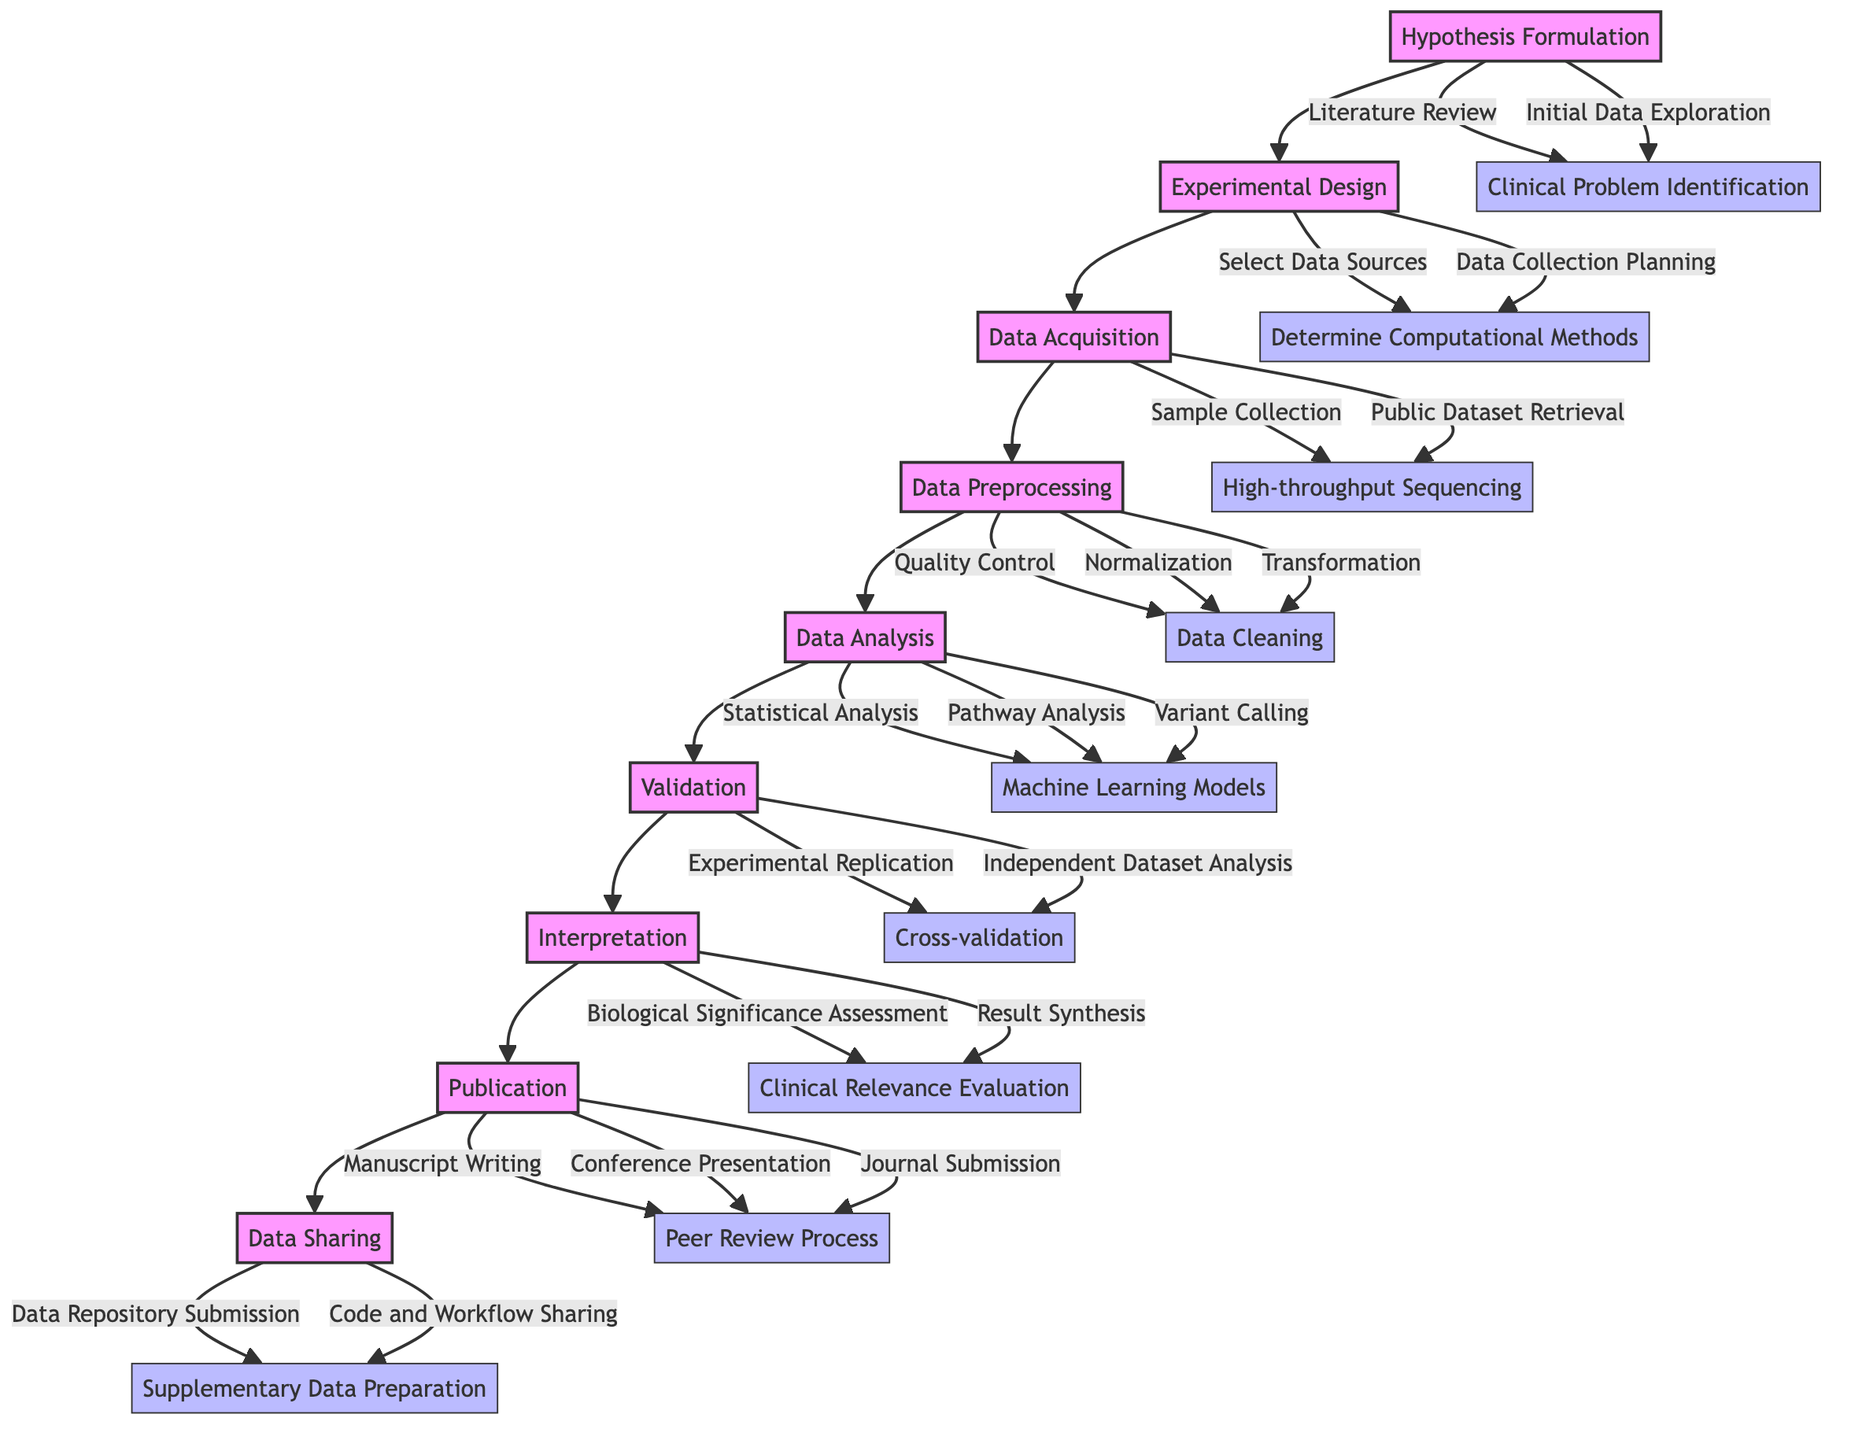What is the first phase in the bioinformatics research project lifecycle? The diagram starts with the first phase labeled "Hypothesis Formulation," indicating that this is the initial step in the project lifecycle.
Answer: Hypothesis Formulation How many main phases are there in the diagram? By counting the main sections connected in the flowchart, I observe that there are a total of nine phases, starting from Hypothesis Formulation and ending with Data Sharing.
Answer: 9 Which phase directly precedes Data Analysis? Following the directional flow in the diagram, Data Preprocessing is the phase that comes immediately before Data Analysis, indicating the order of operations.
Answer: Data Preprocessing What task is associated with the Data Sharing phase? Looking at the tasks listed under the Data Sharing phase in the diagram, one is specifically labeled "Data Repository Submission," which highlights an essential action in that phase.
Answer: Data Repository Submission In which phase would you expect to perform Statistical Analysis? Since the diagram indicates that Data Analysis is where various analyses including Statistical Analysis are conducted, it is clear that this task appears in that specific phase.
Answer: Data Analysis Which task is common to both the Experimental Design and Data Acquisition phases? Observing the chart, "Select Data Sources" appears under Experimental Design and is connected to "Determine Computational Methods," suggesting a link between tasks in both these phases.
Answer: Select Data Sources What is the last phase of the lifecycle? The flowchart depicts the final phase to be Data Sharing, as it directly follows the Publication phase, thereby concluding the research lifecycle.
Answer: Data Sharing Which phase involves the Peer Review Process? Within the Publication phase, the Peer Review Process is explicitly mentioned as one of the tasks that need to be completed in this essential stage of research dissemination.
Answer: Publication How many tasks are involved in the Interpretation phase? The diagram shows three distinct tasks under the Interpretation phase: "Biological Significance Assessment," "Clinical Relevance Evaluation," and "Result Synthesis," meaning there are three tasks total in this phase.
Answer: 3 